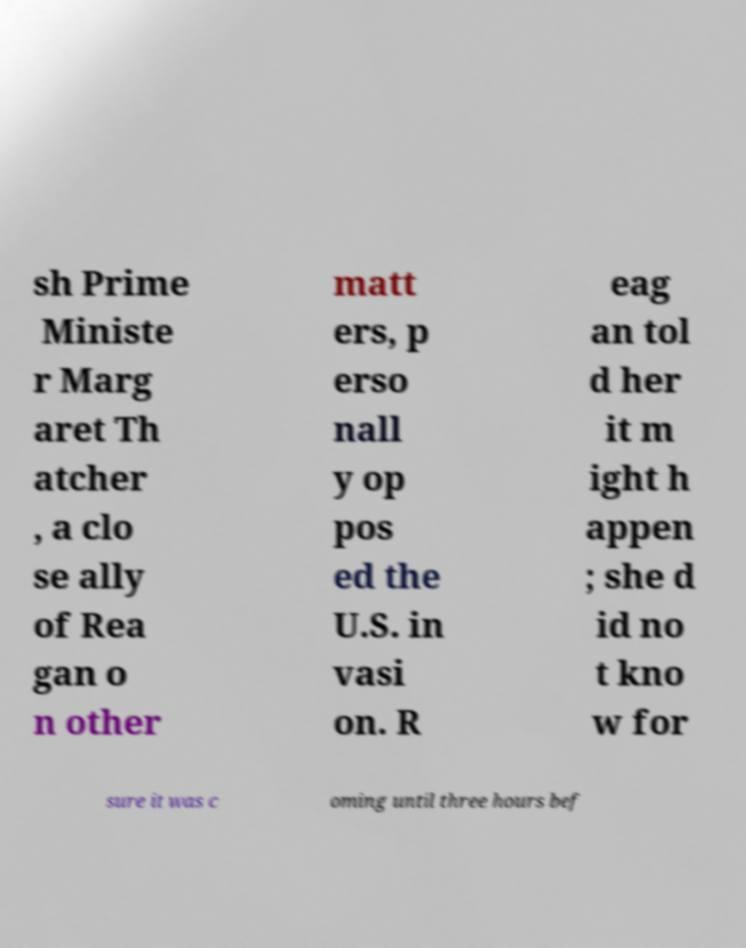For documentation purposes, I need the text within this image transcribed. Could you provide that? sh Prime Ministe r Marg aret Th atcher , a clo se ally of Rea gan o n other matt ers, p erso nall y op pos ed the U.S. in vasi on. R eag an tol d her it m ight h appen ; she d id no t kno w for sure it was c oming until three hours bef 